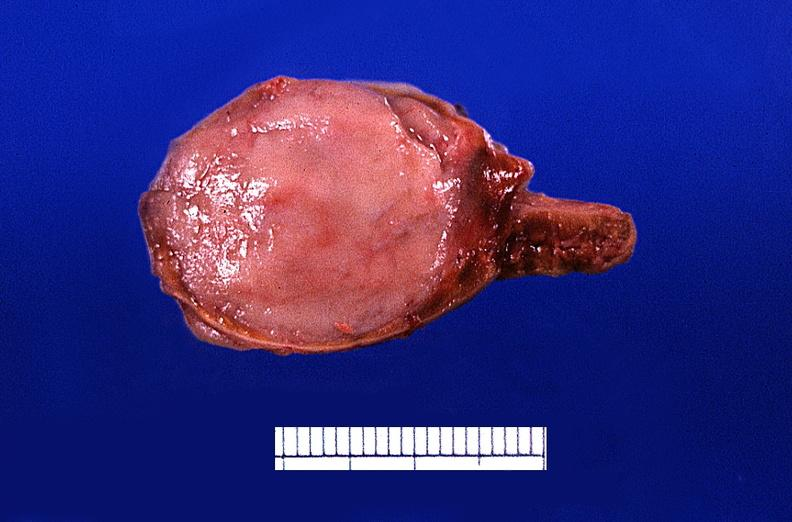what is present?
Answer the question using a single word or phrase. Endocrine 